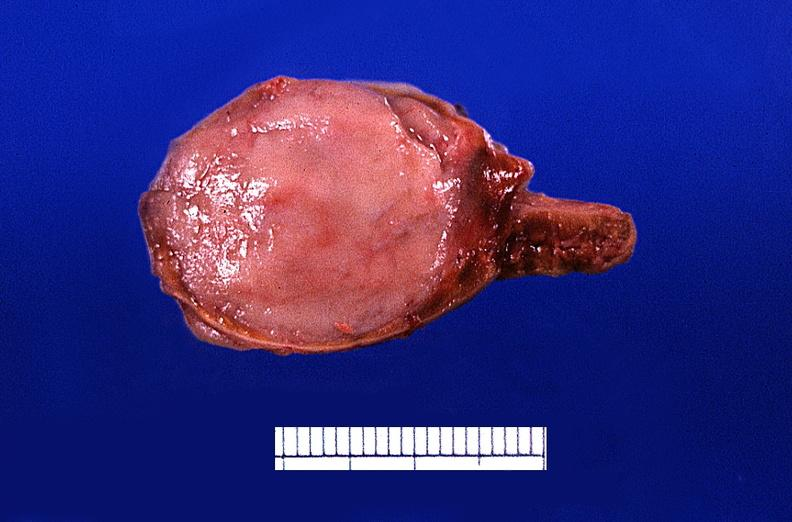what is present?
Answer the question using a single word or phrase. Endocrine 